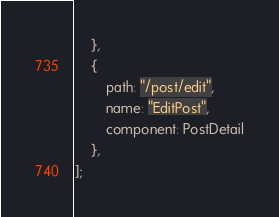<code> <loc_0><loc_0><loc_500><loc_500><_JavaScript_>    },   
    {
        path: "/post/edit",
        name: "EditPost",
        component: PostDetail
    },
];
</code> 